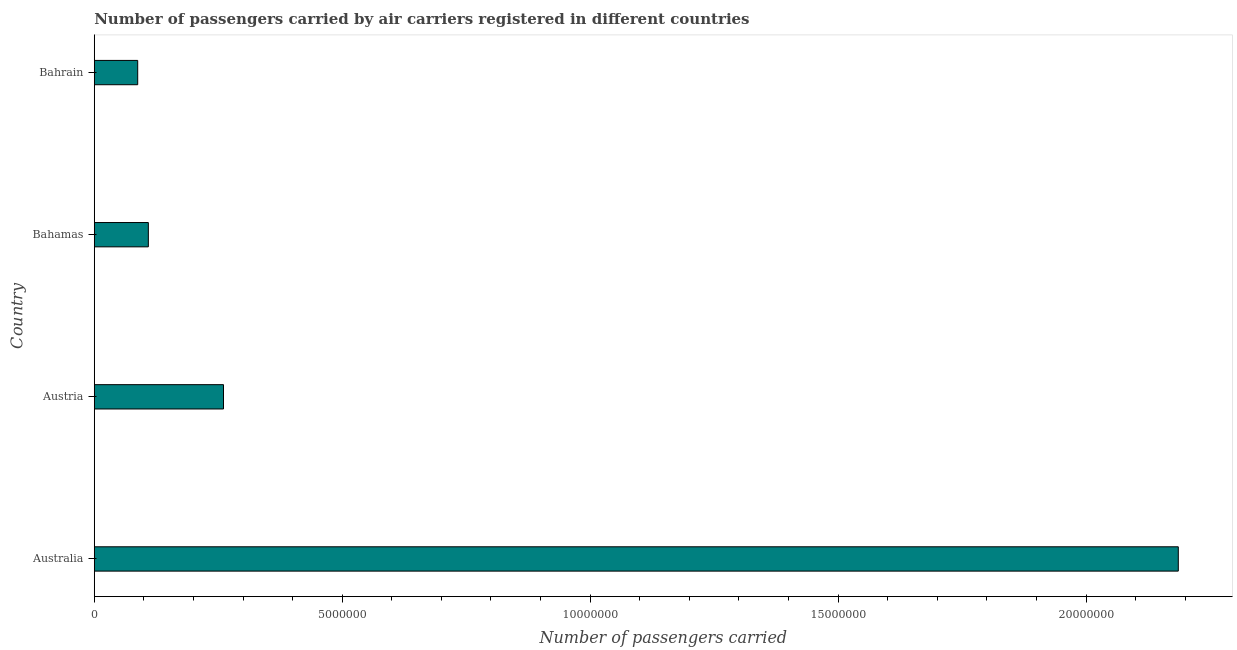Does the graph contain grids?
Your response must be concise. No. What is the title of the graph?
Provide a succinct answer. Number of passengers carried by air carriers registered in different countries. What is the label or title of the X-axis?
Offer a very short reply. Number of passengers carried. What is the number of passengers carried in Australia?
Provide a short and direct response. 2.19e+07. Across all countries, what is the maximum number of passengers carried?
Your response must be concise. 2.19e+07. Across all countries, what is the minimum number of passengers carried?
Your answer should be very brief. 8.76e+05. In which country was the number of passengers carried minimum?
Give a very brief answer. Bahrain. What is the sum of the number of passengers carried?
Offer a very short reply. 2.64e+07. What is the difference between the number of passengers carried in Australia and Bahamas?
Make the answer very short. 2.08e+07. What is the average number of passengers carried per country?
Ensure brevity in your answer.  6.61e+06. What is the median number of passengers carried?
Your response must be concise. 1.85e+06. What is the ratio of the number of passengers carried in Australia to that in Austria?
Offer a very short reply. 8.39. Is the number of passengers carried in Bahamas less than that in Bahrain?
Provide a succinct answer. No. Is the difference between the number of passengers carried in Austria and Bahrain greater than the difference between any two countries?
Offer a terse response. No. What is the difference between the highest and the second highest number of passengers carried?
Keep it short and to the point. 1.93e+07. Is the sum of the number of passengers carried in Austria and Bahrain greater than the maximum number of passengers carried across all countries?
Your answer should be very brief. No. What is the difference between the highest and the lowest number of passengers carried?
Your response must be concise. 2.10e+07. How many countries are there in the graph?
Your answer should be very brief. 4. Are the values on the major ticks of X-axis written in scientific E-notation?
Give a very brief answer. No. What is the Number of passengers carried in Australia?
Your response must be concise. 2.19e+07. What is the Number of passengers carried in Austria?
Give a very brief answer. 2.61e+06. What is the Number of passengers carried of Bahamas?
Your answer should be compact. 1.09e+06. What is the Number of passengers carried of Bahrain?
Keep it short and to the point. 8.76e+05. What is the difference between the Number of passengers carried in Australia and Austria?
Your answer should be very brief. 1.93e+07. What is the difference between the Number of passengers carried in Australia and Bahamas?
Make the answer very short. 2.08e+07. What is the difference between the Number of passengers carried in Australia and Bahrain?
Provide a succinct answer. 2.10e+07. What is the difference between the Number of passengers carried in Austria and Bahamas?
Ensure brevity in your answer.  1.52e+06. What is the difference between the Number of passengers carried in Austria and Bahrain?
Your answer should be very brief. 1.73e+06. What is the difference between the Number of passengers carried in Bahamas and Bahrain?
Offer a terse response. 2.14e+05. What is the ratio of the Number of passengers carried in Australia to that in Austria?
Give a very brief answer. 8.39. What is the ratio of the Number of passengers carried in Australia to that in Bahamas?
Offer a very short reply. 20.05. What is the ratio of the Number of passengers carried in Australia to that in Bahrain?
Offer a terse response. 24.97. What is the ratio of the Number of passengers carried in Austria to that in Bahamas?
Ensure brevity in your answer.  2.39. What is the ratio of the Number of passengers carried in Austria to that in Bahrain?
Offer a terse response. 2.98. What is the ratio of the Number of passengers carried in Bahamas to that in Bahrain?
Offer a terse response. 1.25. 